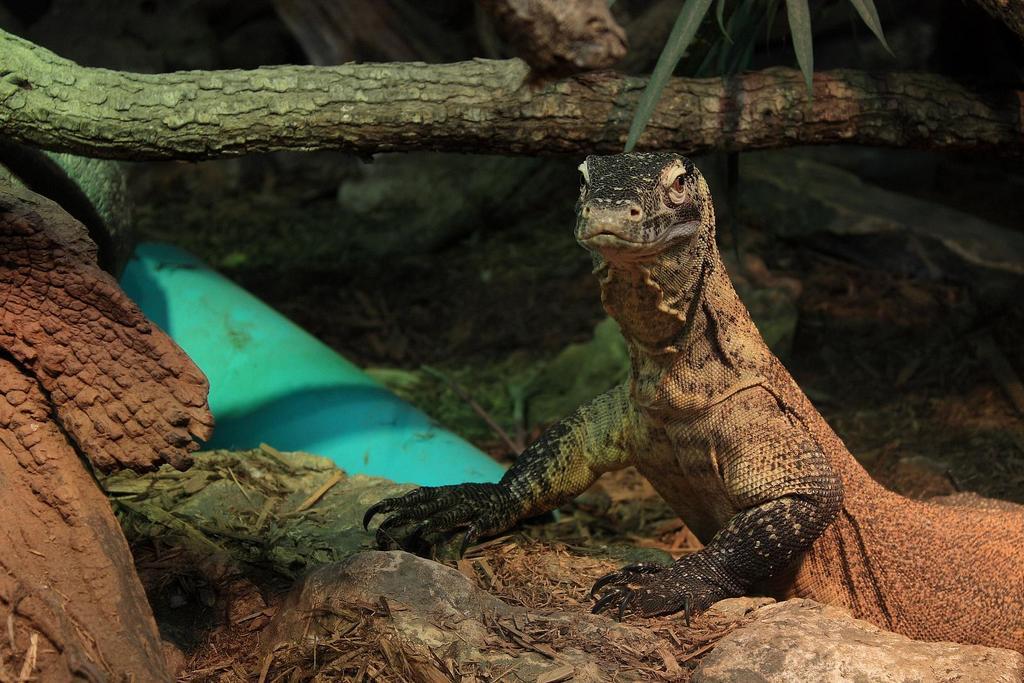How would you summarize this image in a sentence or two? In this image I can see the reptile which is in black and brown color. To the side of the reptile I can see the tree trunks, blue color object and the plants. 